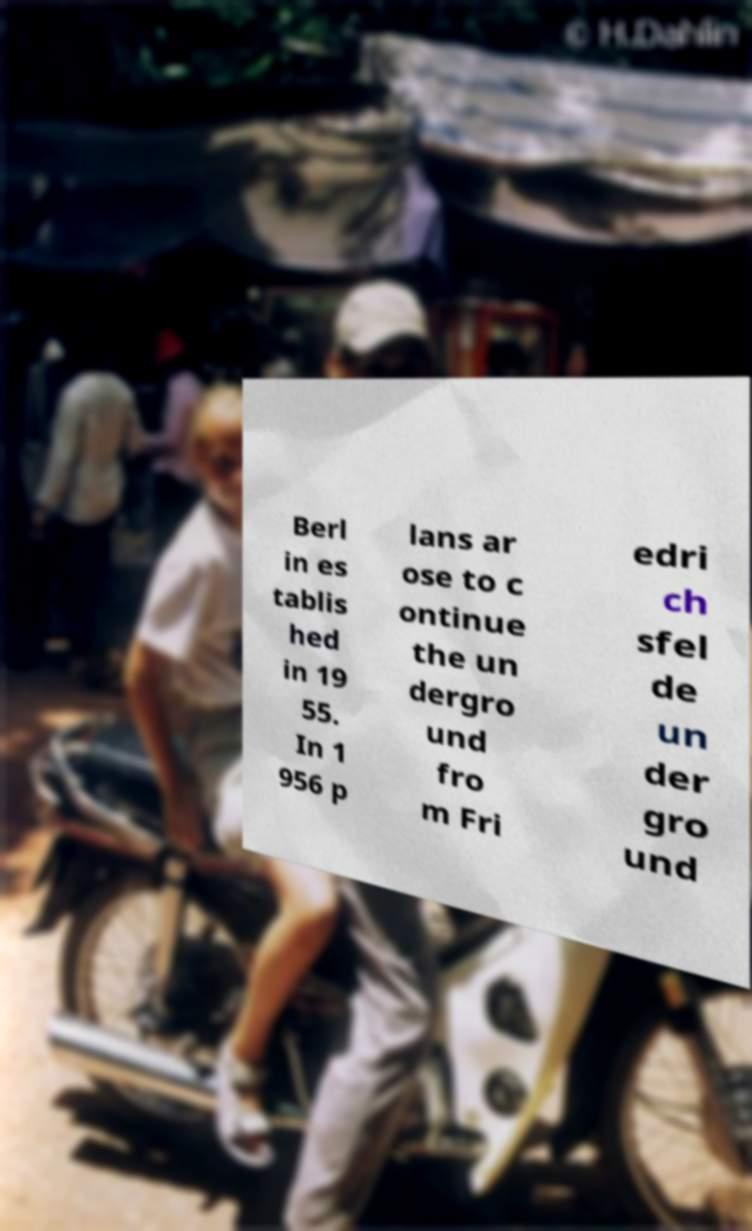Can you accurately transcribe the text from the provided image for me? Berl in es tablis hed in 19 55. In 1 956 p lans ar ose to c ontinue the un dergro und fro m Fri edri ch sfel de un der gro und 